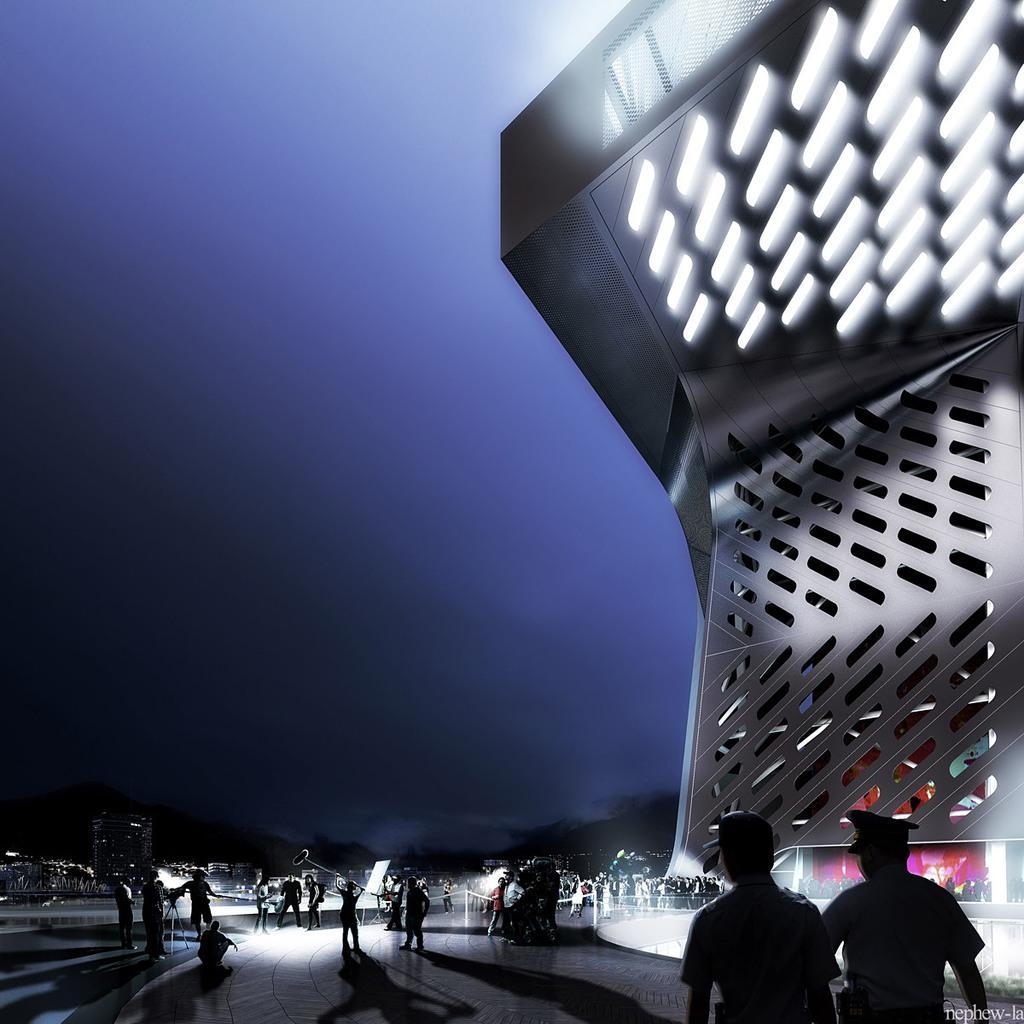Please provide a concise description of this image. In this image in the center there are persons standing and walking. On the right side there is a structure. 